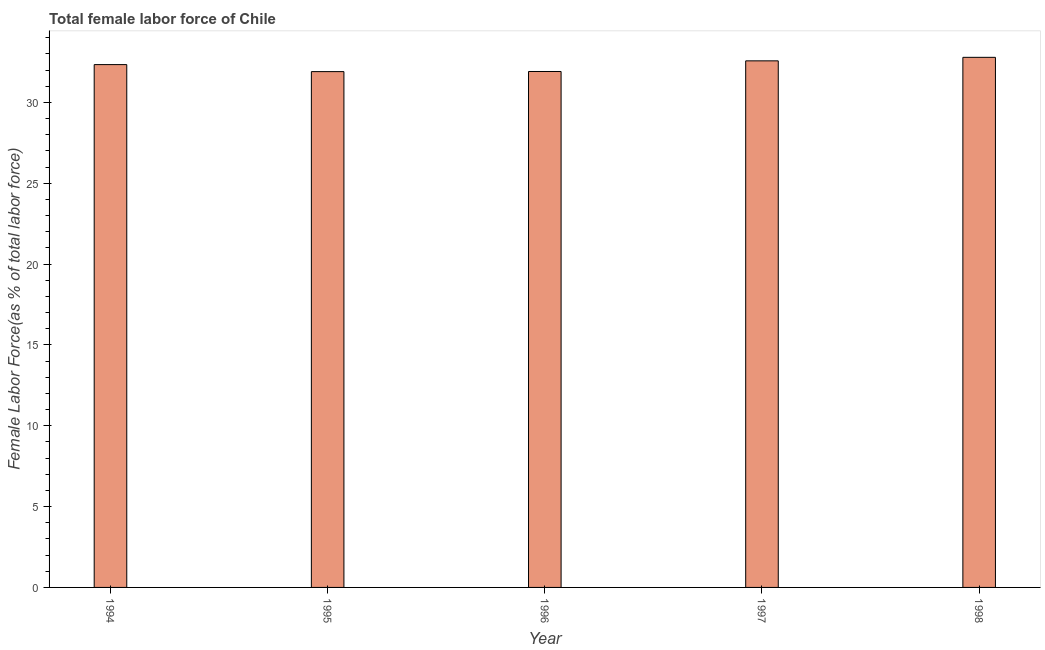Does the graph contain any zero values?
Your answer should be compact. No. Does the graph contain grids?
Give a very brief answer. No. What is the title of the graph?
Your response must be concise. Total female labor force of Chile. What is the label or title of the X-axis?
Provide a succinct answer. Year. What is the label or title of the Y-axis?
Your answer should be compact. Female Labor Force(as % of total labor force). What is the total female labor force in 1997?
Provide a succinct answer. 32.57. Across all years, what is the maximum total female labor force?
Your answer should be very brief. 32.79. Across all years, what is the minimum total female labor force?
Offer a very short reply. 31.9. In which year was the total female labor force maximum?
Your answer should be very brief. 1998. What is the sum of the total female labor force?
Keep it short and to the point. 161.5. What is the difference between the total female labor force in 1995 and 1996?
Ensure brevity in your answer.  -0.01. What is the average total female labor force per year?
Give a very brief answer. 32.3. What is the median total female labor force?
Offer a terse response. 32.34. In how many years, is the total female labor force greater than 1 %?
Ensure brevity in your answer.  5. What is the ratio of the total female labor force in 1995 to that in 1998?
Provide a short and direct response. 0.97. Is the total female labor force in 1995 less than that in 1996?
Ensure brevity in your answer.  Yes. What is the difference between the highest and the second highest total female labor force?
Give a very brief answer. 0.22. What is the difference between the highest and the lowest total female labor force?
Give a very brief answer. 0.88. In how many years, is the total female labor force greater than the average total female labor force taken over all years?
Your answer should be very brief. 3. How many bars are there?
Give a very brief answer. 5. How many years are there in the graph?
Provide a short and direct response. 5. What is the difference between two consecutive major ticks on the Y-axis?
Ensure brevity in your answer.  5. What is the Female Labor Force(as % of total labor force) in 1994?
Offer a terse response. 32.34. What is the Female Labor Force(as % of total labor force) of 1995?
Your response must be concise. 31.9. What is the Female Labor Force(as % of total labor force) in 1996?
Ensure brevity in your answer.  31.91. What is the Female Labor Force(as % of total labor force) of 1997?
Make the answer very short. 32.57. What is the Female Labor Force(as % of total labor force) of 1998?
Ensure brevity in your answer.  32.79. What is the difference between the Female Labor Force(as % of total labor force) in 1994 and 1995?
Make the answer very short. 0.43. What is the difference between the Female Labor Force(as % of total labor force) in 1994 and 1996?
Your response must be concise. 0.43. What is the difference between the Female Labor Force(as % of total labor force) in 1994 and 1997?
Your response must be concise. -0.23. What is the difference between the Female Labor Force(as % of total labor force) in 1994 and 1998?
Give a very brief answer. -0.45. What is the difference between the Female Labor Force(as % of total labor force) in 1995 and 1996?
Give a very brief answer. -0.01. What is the difference between the Female Labor Force(as % of total labor force) in 1995 and 1997?
Your response must be concise. -0.67. What is the difference between the Female Labor Force(as % of total labor force) in 1995 and 1998?
Make the answer very short. -0.88. What is the difference between the Female Labor Force(as % of total labor force) in 1996 and 1997?
Ensure brevity in your answer.  -0.66. What is the difference between the Female Labor Force(as % of total labor force) in 1996 and 1998?
Provide a succinct answer. -0.88. What is the difference between the Female Labor Force(as % of total labor force) in 1997 and 1998?
Provide a succinct answer. -0.22. What is the ratio of the Female Labor Force(as % of total labor force) in 1994 to that in 1996?
Give a very brief answer. 1.01. What is the ratio of the Female Labor Force(as % of total labor force) in 1995 to that in 1996?
Your answer should be very brief. 1. What is the ratio of the Female Labor Force(as % of total labor force) in 1995 to that in 1998?
Offer a very short reply. 0.97. What is the ratio of the Female Labor Force(as % of total labor force) in 1996 to that in 1997?
Provide a succinct answer. 0.98. What is the ratio of the Female Labor Force(as % of total labor force) in 1997 to that in 1998?
Provide a short and direct response. 0.99. 